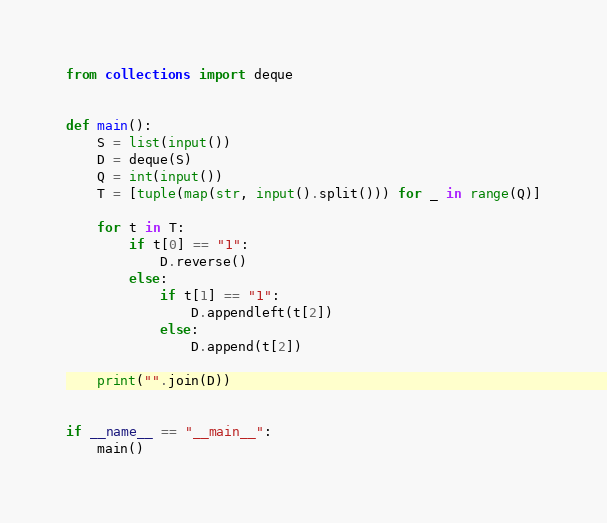Convert code to text. <code><loc_0><loc_0><loc_500><loc_500><_Python_>from collections import deque


def main():
    S = list(input())
    D = deque(S)
    Q = int(input())
    T = [tuple(map(str, input().split())) for _ in range(Q)]

    for t in T:
        if t[0] == "1":
            D.reverse()
        else:
            if t[1] == "1":
                D.appendleft(t[2])
            else:
                D.append(t[2])

    print("".join(D))


if __name__ == "__main__":
    main()
</code> 